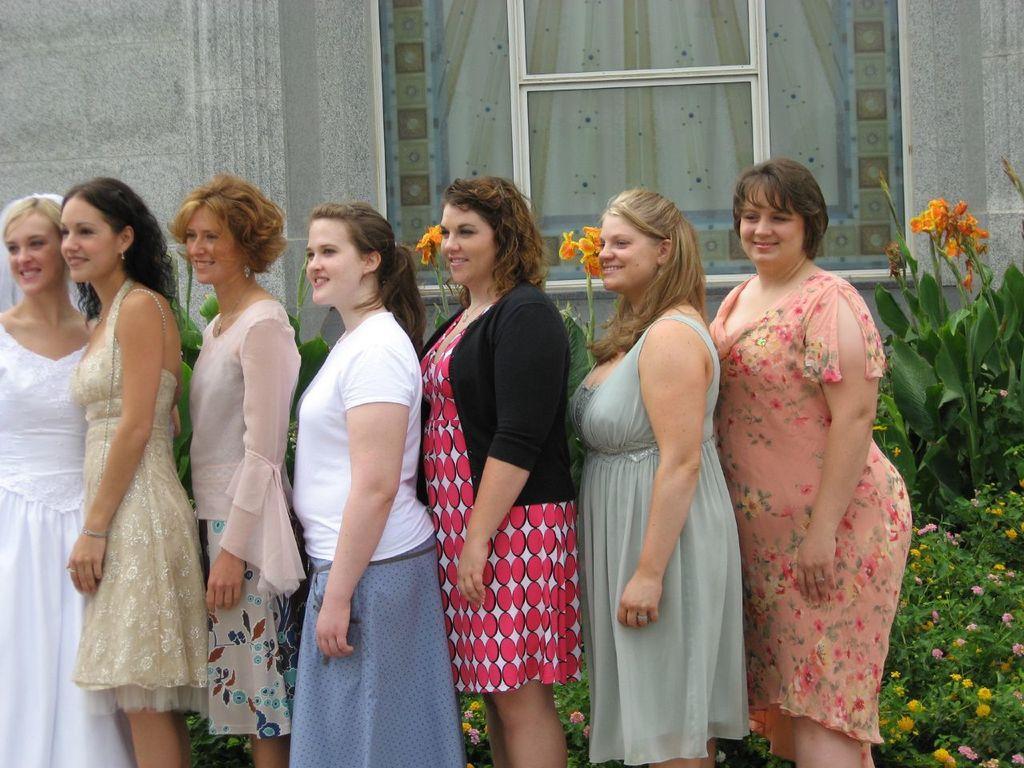In one or two sentences, can you explain what this image depicts? In this picture there are group of people standing and smiling. At the back there is a building and there are plants and flowers and there is a board behind the window. 